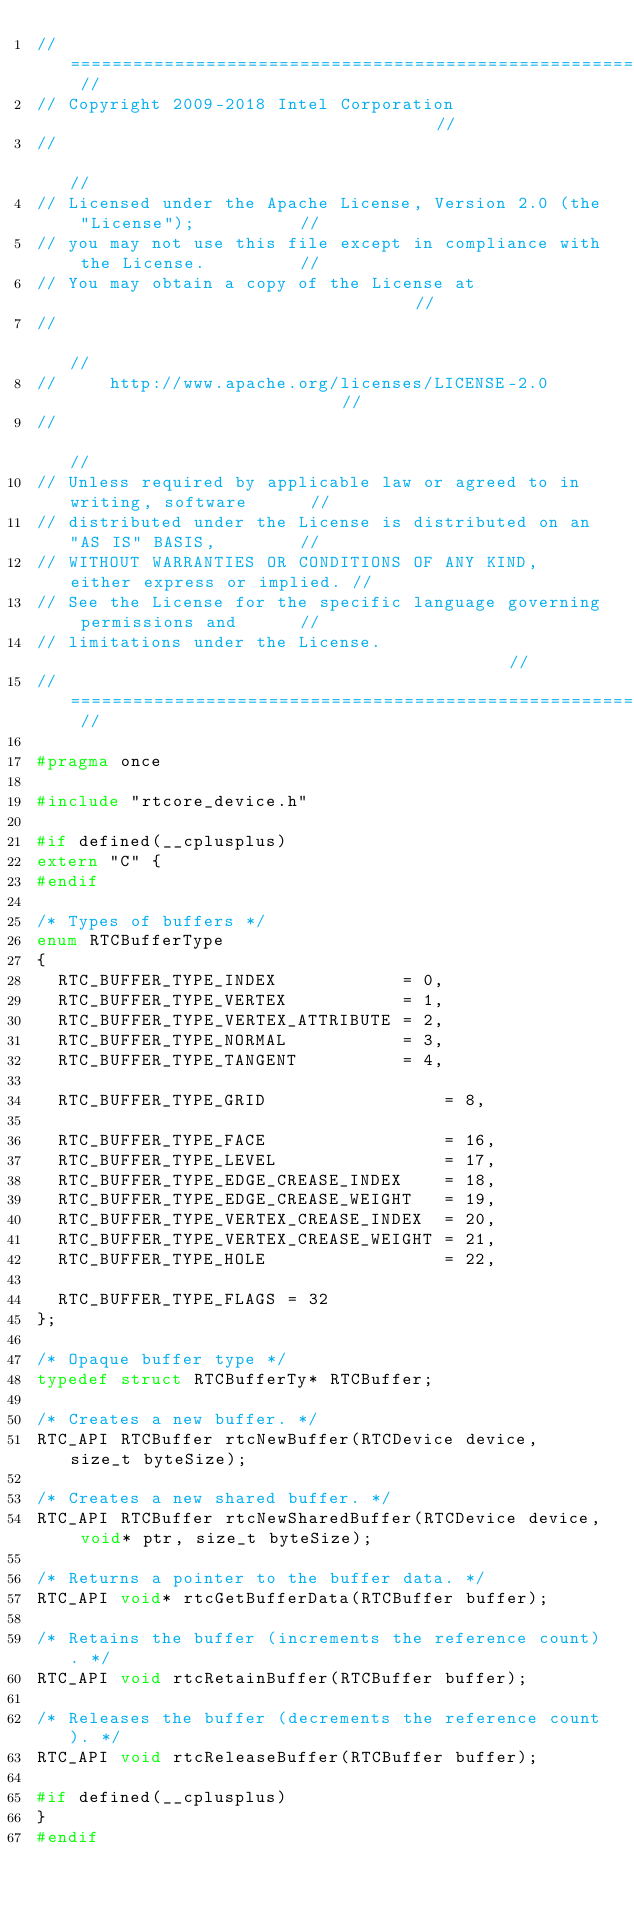Convert code to text. <code><loc_0><loc_0><loc_500><loc_500><_C_>// ======================================================================== //
// Copyright 2009-2018 Intel Corporation                                    //
//                                                                          //
// Licensed under the Apache License, Version 2.0 (the "License");          //
// you may not use this file except in compliance with the License.         //
// You may obtain a copy of the License at                                  //
//                                                                          //
//     http://www.apache.org/licenses/LICENSE-2.0                           //
//                                                                          //
// Unless required by applicable law or agreed to in writing, software      //
// distributed under the License is distributed on an "AS IS" BASIS,        //
// WITHOUT WARRANTIES OR CONDITIONS OF ANY KIND, either express or implied. //
// See the License for the specific language governing permissions and      //
// limitations under the License.                                           //
// ======================================================================== //

#pragma once

#include "rtcore_device.h"

#if defined(__cplusplus)
extern "C" {
#endif

/* Types of buffers */
enum RTCBufferType
{
  RTC_BUFFER_TYPE_INDEX            = 0,
  RTC_BUFFER_TYPE_VERTEX           = 1,
  RTC_BUFFER_TYPE_VERTEX_ATTRIBUTE = 2,
  RTC_BUFFER_TYPE_NORMAL           = 3,
  RTC_BUFFER_TYPE_TANGENT          = 4,

  RTC_BUFFER_TYPE_GRID                 = 8,

  RTC_BUFFER_TYPE_FACE                 = 16,
  RTC_BUFFER_TYPE_LEVEL                = 17,
  RTC_BUFFER_TYPE_EDGE_CREASE_INDEX    = 18,
  RTC_BUFFER_TYPE_EDGE_CREASE_WEIGHT   = 19,
  RTC_BUFFER_TYPE_VERTEX_CREASE_INDEX  = 20,
  RTC_BUFFER_TYPE_VERTEX_CREASE_WEIGHT = 21,
  RTC_BUFFER_TYPE_HOLE                 = 22,

  RTC_BUFFER_TYPE_FLAGS = 32
};

/* Opaque buffer type */
typedef struct RTCBufferTy* RTCBuffer;

/* Creates a new buffer. */
RTC_API RTCBuffer rtcNewBuffer(RTCDevice device, size_t byteSize);

/* Creates a new shared buffer. */
RTC_API RTCBuffer rtcNewSharedBuffer(RTCDevice device, void* ptr, size_t byteSize);

/* Returns a pointer to the buffer data. */
RTC_API void* rtcGetBufferData(RTCBuffer buffer);

/* Retains the buffer (increments the reference count). */
RTC_API void rtcRetainBuffer(RTCBuffer buffer);

/* Releases the buffer (decrements the reference count). */
RTC_API void rtcReleaseBuffer(RTCBuffer buffer);

#if defined(__cplusplus)
}
#endif
</code> 